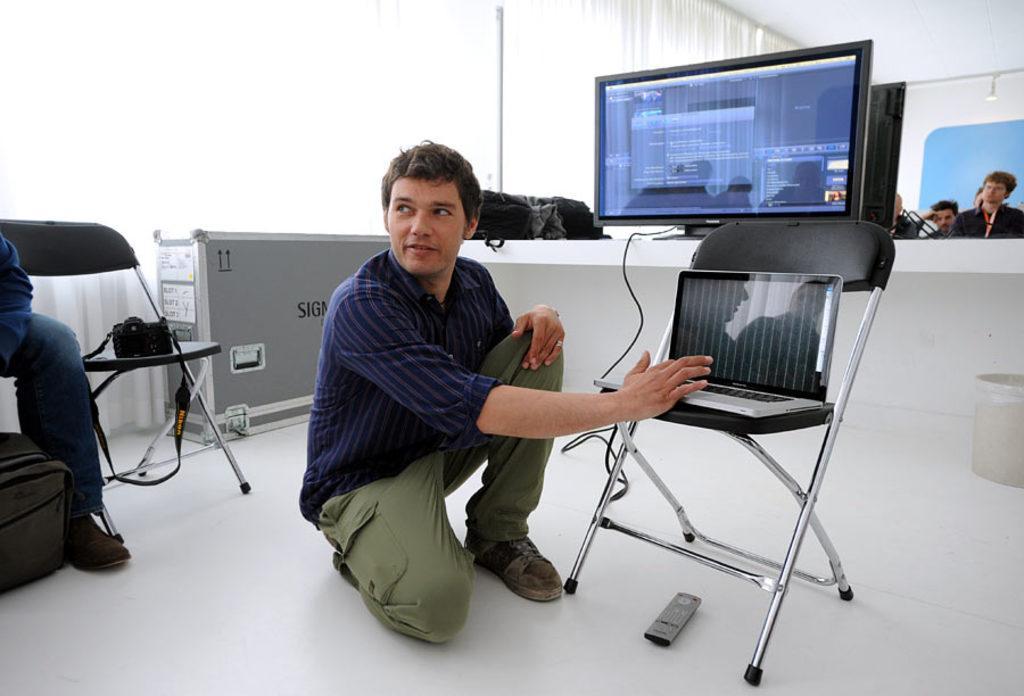In one or two sentences, can you explain what this image depicts? In this image there are people and we can see chairs. There is a camera, bag and a laptop. We can see a screen placed on the table and there are clothes. In the background there is a wall and we can see curtains. At the bottom there is a remote and a bin. 